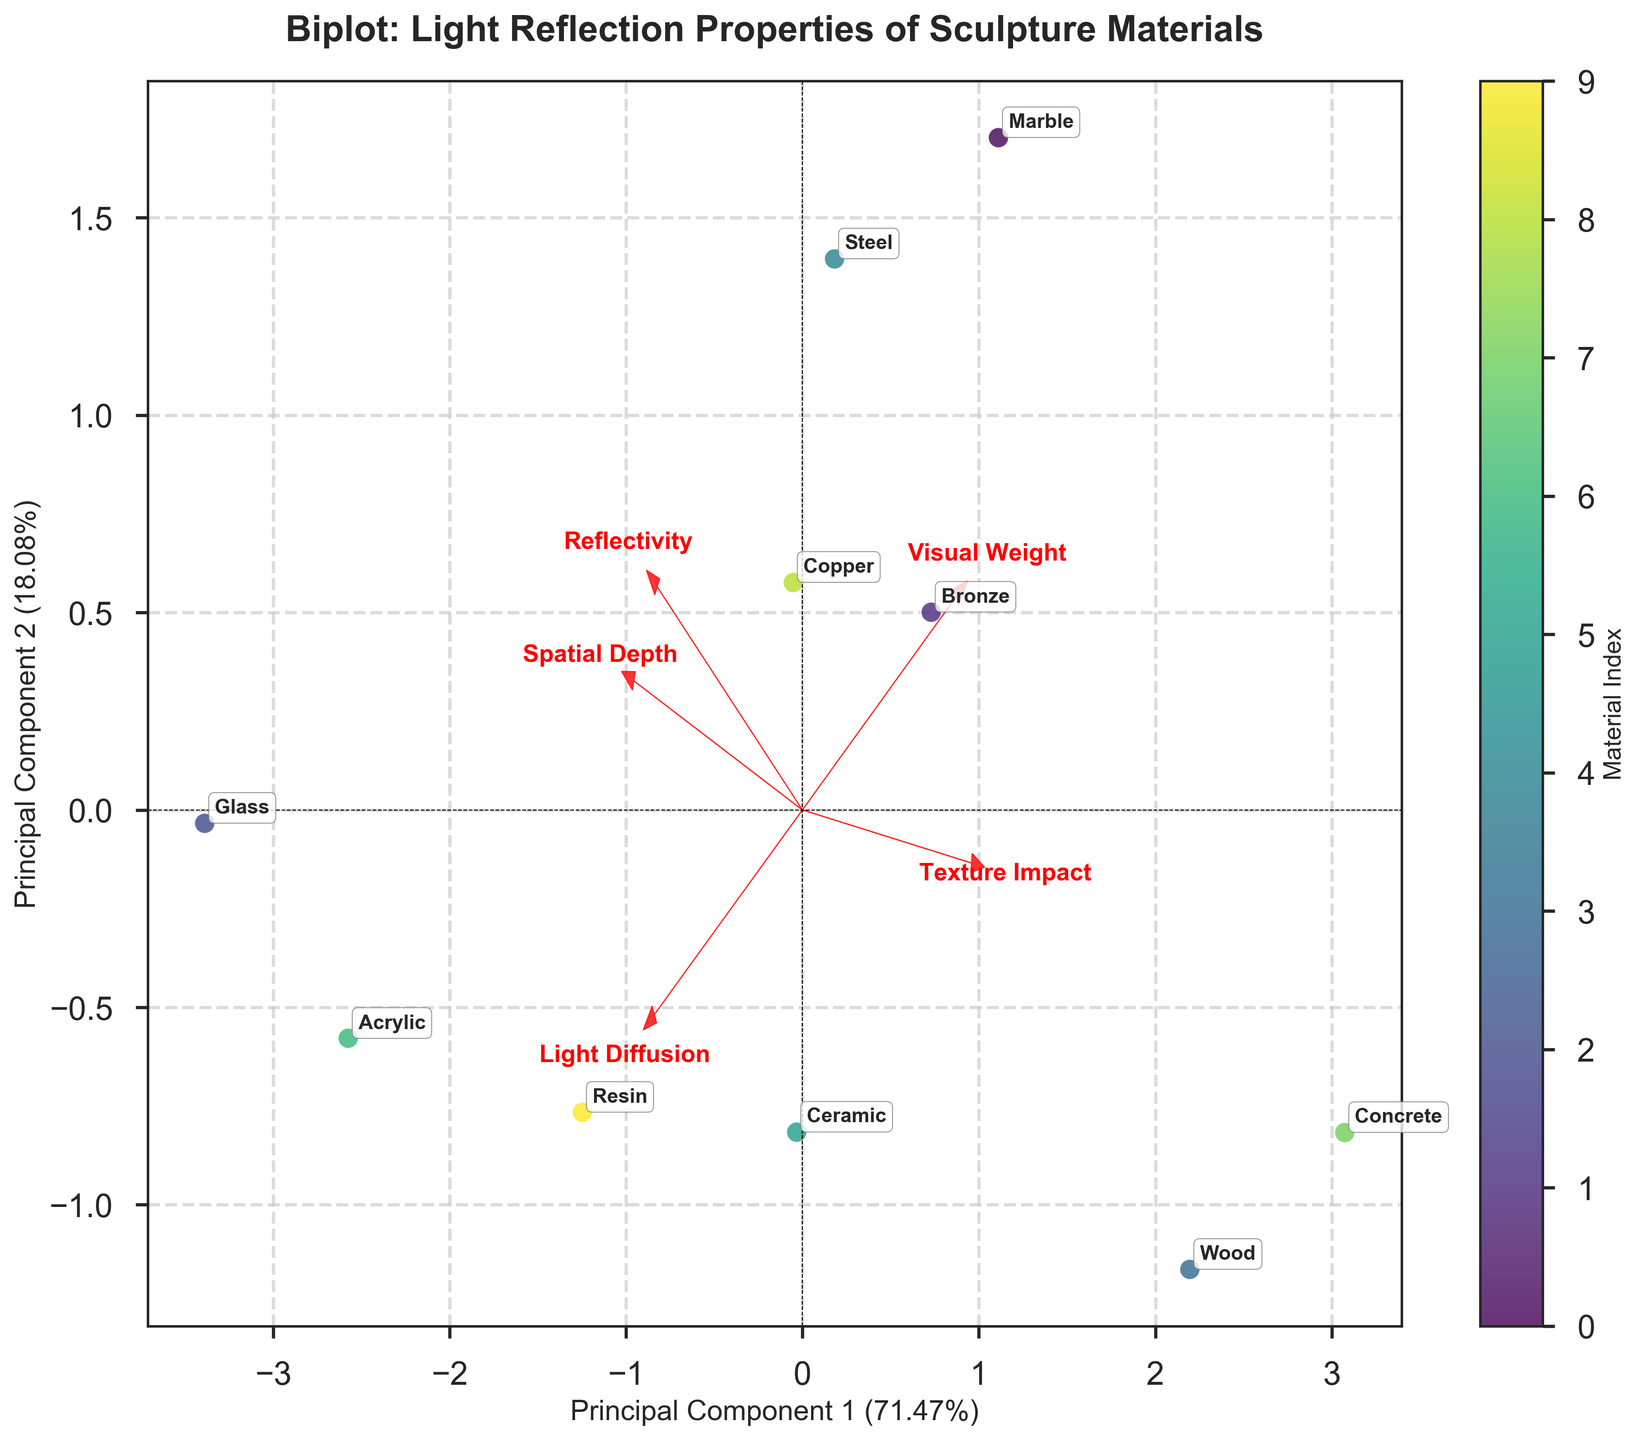How many materials are represented in the biplot? Count the number of unique material labels displayed in the figure. Each label corresponds to a different material.
Answer: 10 What are the two main components labeled on the axes? The x-axis and y-axis are labeled with the first and second principal components, respectively. Read the titles of the axes to find the names of these components.
Answer: Principal Component 1 and Principal Component 2 Which material has the highest reflectivity according to the biplot? Identify the material label that is closest to the arrow representing the 'Reflectivity' loading vector. The direction of this arrow indicates high values of reflectivity.
Answer: Glass What material appears closest to the center of the biplot? Find the material label that is nearest to the origin (0,0) of the plot. This material's properties are most average in terms of principal component scores.
Answer: Ceramic How do light diffusion and visual weight vectors relate spatially on the biplot? Observe the directions of the arrows representing 'Light Diffusion' and 'Visual Weight'. Note if they are pointing in the same direction or opposite directions relative to each other.
Answer: Opposite directions Which material is associated with both high light diffusion and high spatial depth? Identify the material label located in the direction where both 'Light Diffusion' and 'Spatial Depth' arrows point. This material should be situated somewhere along the combo direction of these vectors.
Answer: Resin What materials are clustered together and what might this indicate? Look for groups of material labels that appear close to each other in the biplot. Clusters might indicate that these materials have similar properties in terms of the principal components.
Answer: Bronze, Copper, Marble (similar reflectivity and spatial depth) Which material contributes most to the variance captured by Principal Component 2? Find the material with the highest absolute value in the direction of the y-axis (Principal Component 2), indicating it contributes significantly to the variance explained by this principal component.
Answer: Glass How does the texture impact correlate with reflectivity in the biplot? Compare the direction of the 'Texture Impact' and 'Reflectivity' arrows. If they point in similar directions, there's a positive correlation; if opposite, there's a negative correlation.
Answer: Positively correlated Which material shows a high visual weight but low light diffusion on the biplot? Identify the material that lies in the direction of the 'Visual Weight' arrow but is opposite to the direction of the 'Light Diffusion' arrow. This indicates high values for visual weight and low for light diffusion.
Answer: Marble 